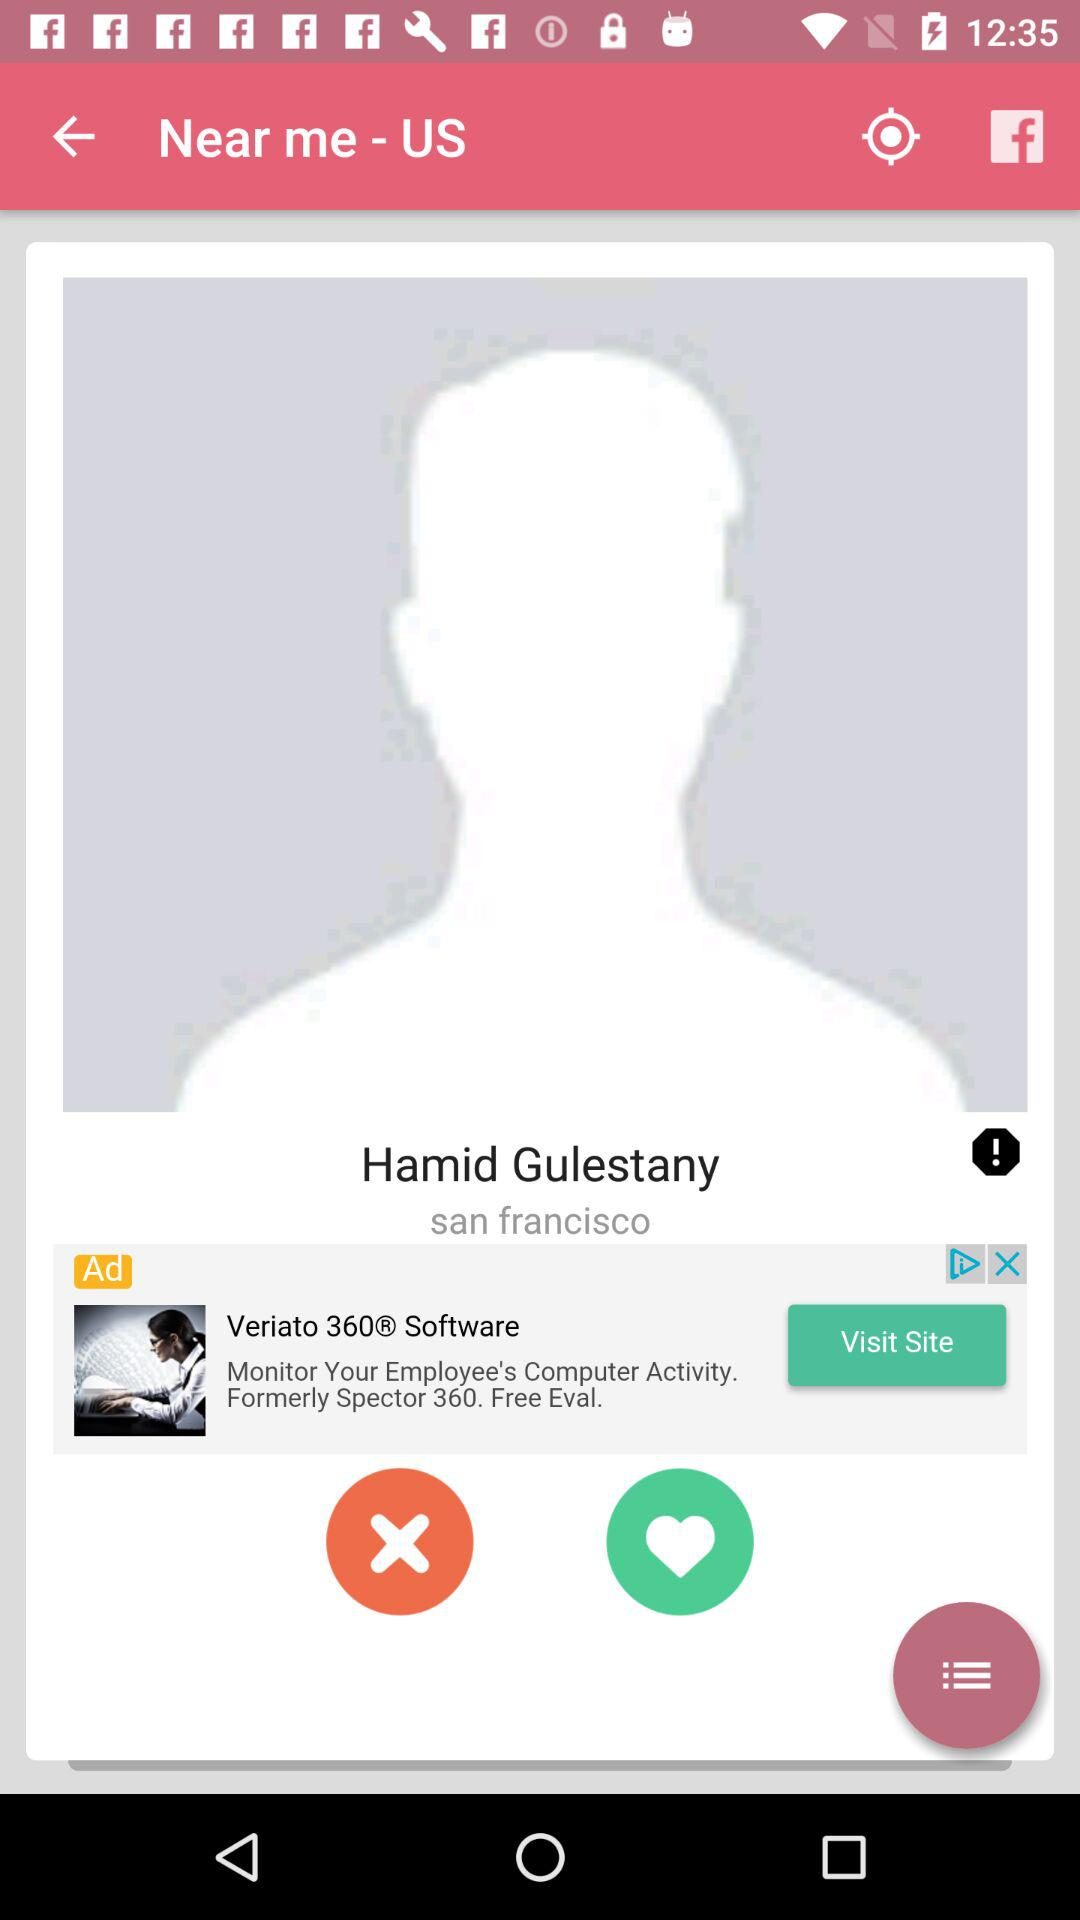What is the location? The location is San Francisco. 